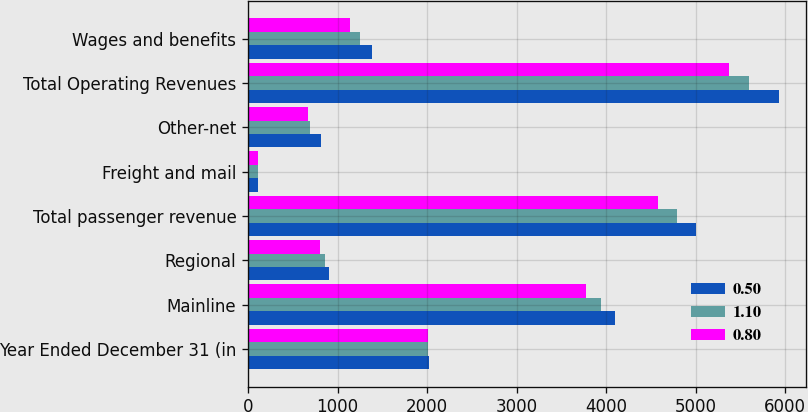Convert chart. <chart><loc_0><loc_0><loc_500><loc_500><stacked_bar_chart><ecel><fcel>Year Ended December 31 (in<fcel>Mainline<fcel>Regional<fcel>Total passenger revenue<fcel>Freight and mail<fcel>Other-net<fcel>Total Operating Revenues<fcel>Wages and benefits<nl><fcel>0.5<fcel>2016<fcel>4098<fcel>908<fcel>5006<fcel>108<fcel>817<fcel>5931<fcel>1382<nl><fcel>1.1<fcel>2015<fcel>3939<fcel>854<fcel>4793<fcel>108<fcel>697<fcel>5598<fcel>1254<nl><fcel>0.8<fcel>2014<fcel>3774<fcel>805<fcel>4579<fcel>114<fcel>675<fcel>5368<fcel>1136<nl></chart> 